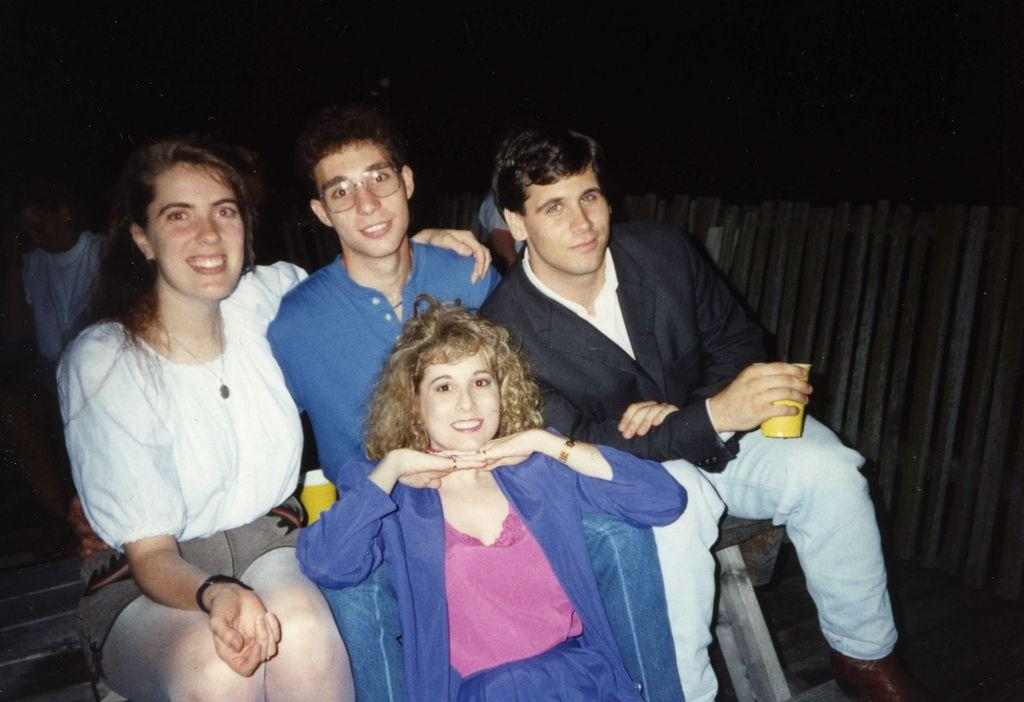How many people are present in the image? There are four people in the image. What are the people in the image doing? The people are sitting and posing for a picture. Can you describe the lighting condition in the image? The image was clicked in the dark. What type of throat-soothing remedy can be seen in the image? There is no throat-soothing remedy present in the image. What kind of experience can be gained from looking at the image? The image itself does not provide an experience, but it may evoke emotions or memories for the viewer. 